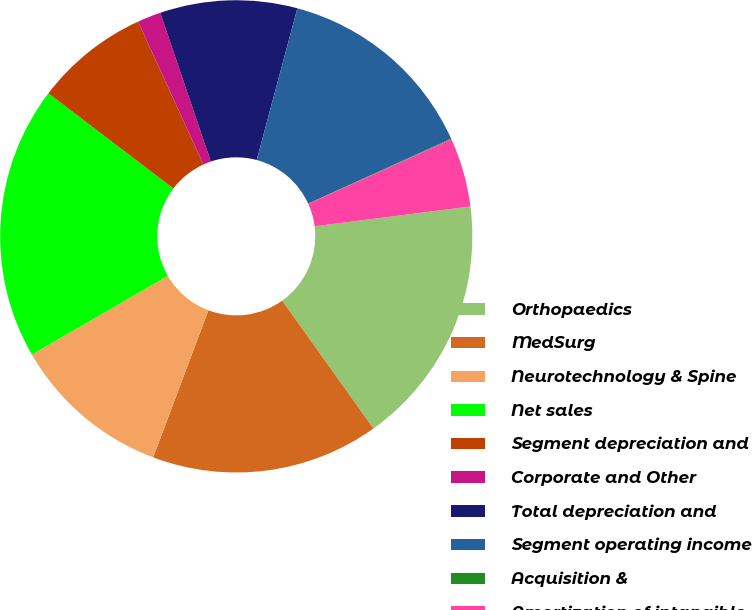Convert chart to OTSL. <chart><loc_0><loc_0><loc_500><loc_500><pie_chart><fcel>Orthopaedics<fcel>MedSurg<fcel>Neurotechnology & Spine<fcel>Net sales<fcel>Segment depreciation and<fcel>Corporate and Other<fcel>Total depreciation and<fcel>Segment operating income<fcel>Acquisition &<fcel>Amortization of intangible<nl><fcel>17.15%<fcel>15.59%<fcel>10.93%<fcel>18.7%<fcel>7.82%<fcel>1.61%<fcel>9.38%<fcel>14.04%<fcel>0.05%<fcel>4.72%<nl></chart> 